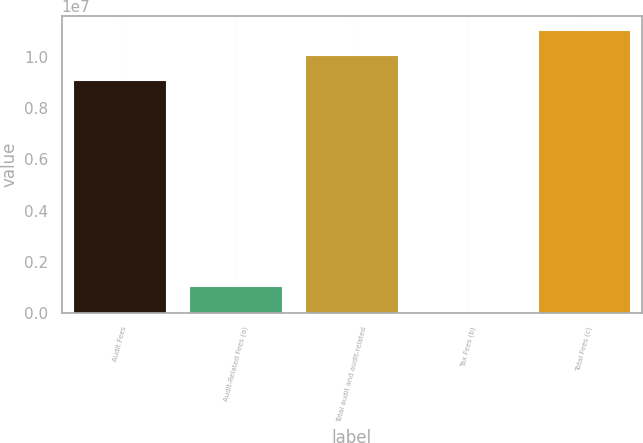Convert chart to OTSL. <chart><loc_0><loc_0><loc_500><loc_500><bar_chart><fcel>Audit Fees<fcel>Audit-Related Fees (a)<fcel>Total audit and audit-related<fcel>Tax Fees (b)<fcel>Total Fees (c)<nl><fcel>9.09687e+06<fcel>1.02977e+06<fcel>1.00806e+07<fcel>46083<fcel>1.10642e+07<nl></chart> 